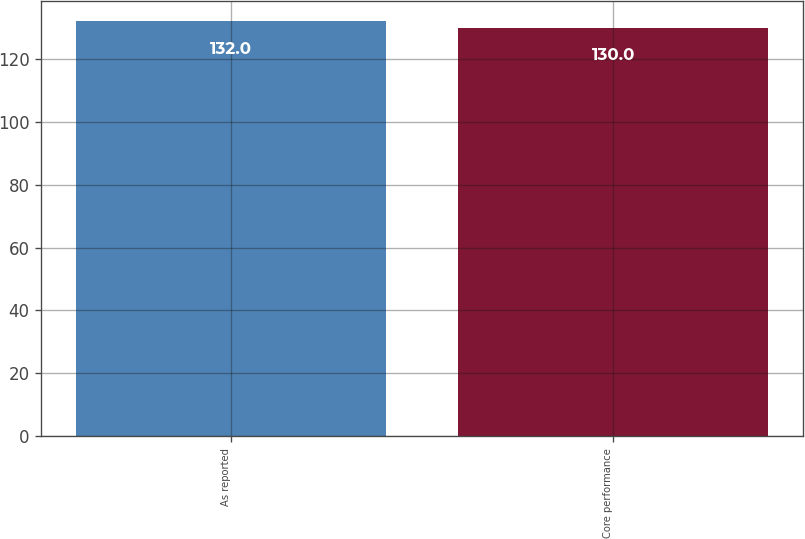<chart> <loc_0><loc_0><loc_500><loc_500><bar_chart><fcel>As reported<fcel>Core performance<nl><fcel>132<fcel>130<nl></chart> 